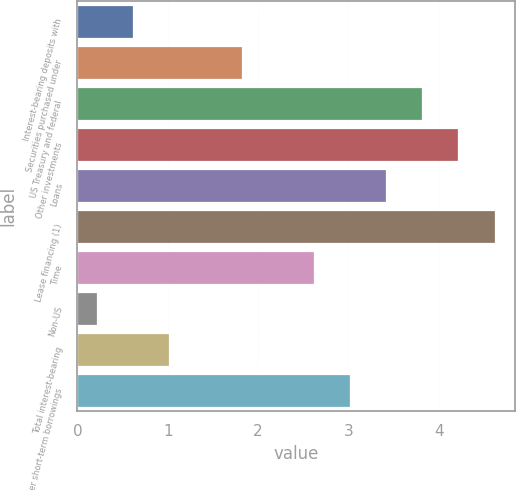Convert chart to OTSL. <chart><loc_0><loc_0><loc_500><loc_500><bar_chart><fcel>Interest-bearing deposits with<fcel>Securities purchased under<fcel>US Treasury and federal<fcel>Other investments<fcel>Loans<fcel>Lease financing (1)<fcel>Time<fcel>Non-US<fcel>Total interest-bearing<fcel>Other short-term borrowings<nl><fcel>0.62<fcel>1.82<fcel>3.82<fcel>4.22<fcel>3.42<fcel>4.62<fcel>2.62<fcel>0.22<fcel>1.02<fcel>3.02<nl></chart> 